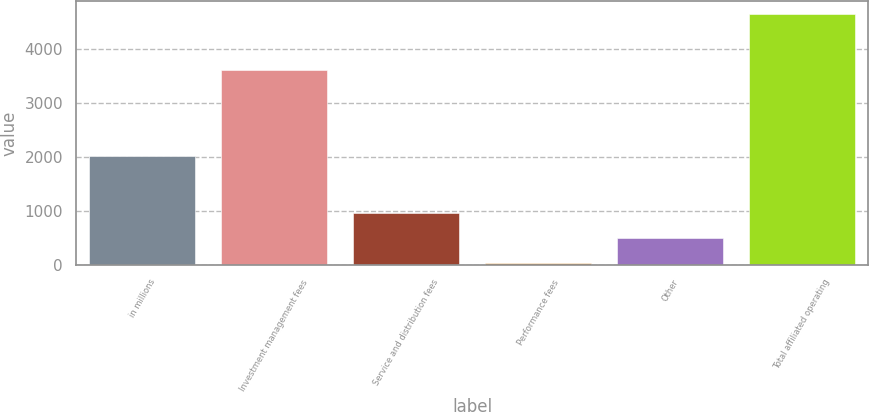Convert chart to OTSL. <chart><loc_0><loc_0><loc_500><loc_500><bar_chart><fcel>in millions<fcel>Investment management fees<fcel>Service and distribution fees<fcel>Performance fees<fcel>Other<fcel>Total affiliated operating<nl><fcel>2014<fcel>3609.8<fcel>961.16<fcel>39<fcel>500.08<fcel>4649.8<nl></chart> 